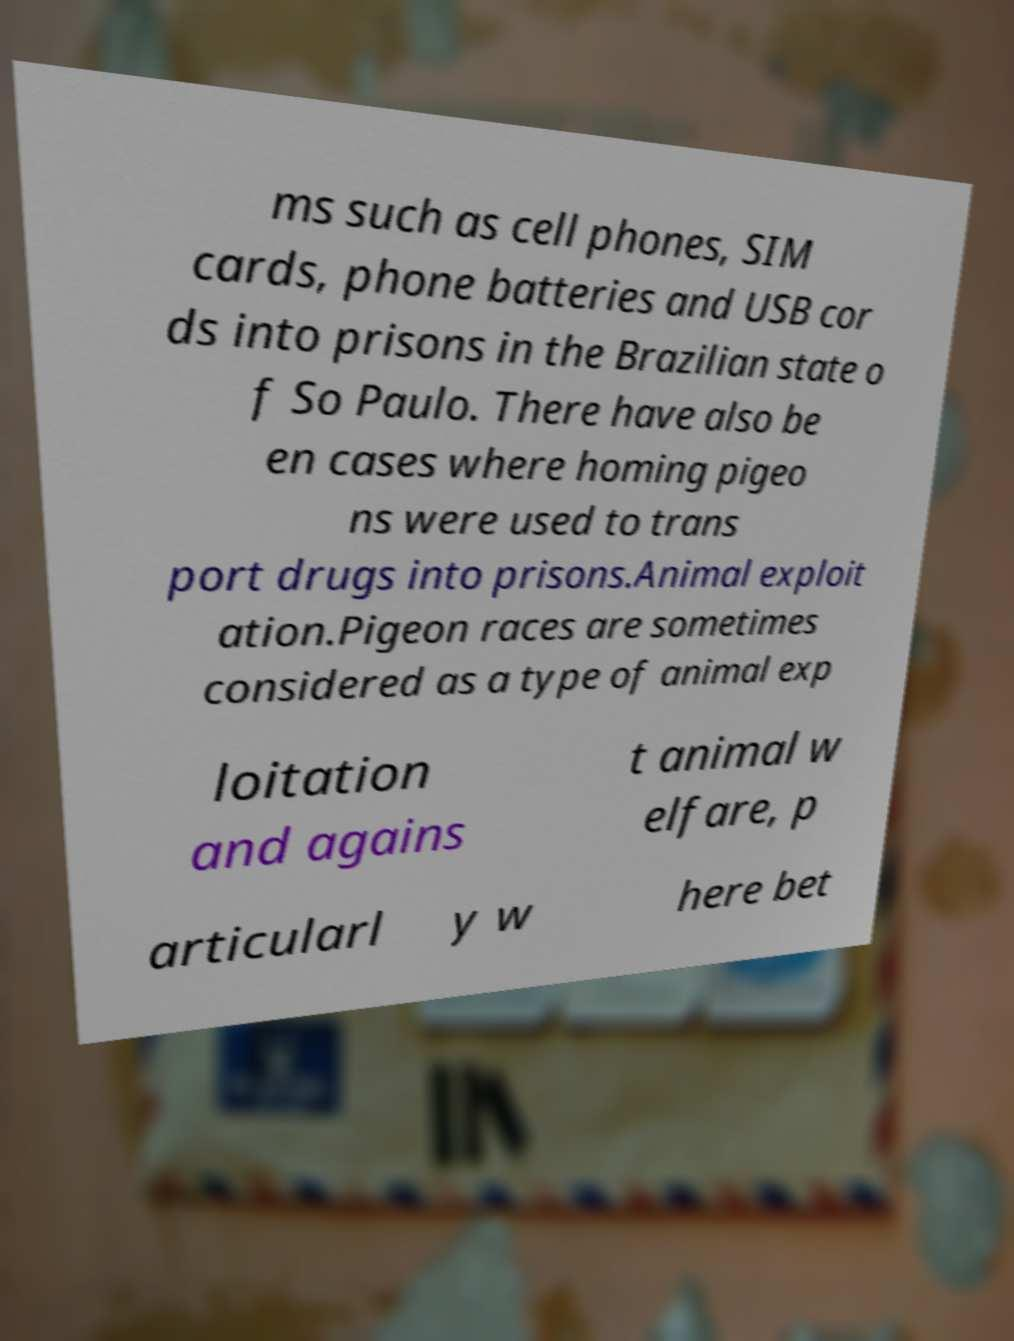Can you read and provide the text displayed in the image?This photo seems to have some interesting text. Can you extract and type it out for me? ms such as cell phones, SIM cards, phone batteries and USB cor ds into prisons in the Brazilian state o f So Paulo. There have also be en cases where homing pigeo ns were used to trans port drugs into prisons.Animal exploit ation.Pigeon races are sometimes considered as a type of animal exp loitation and agains t animal w elfare, p articularl y w here bet 